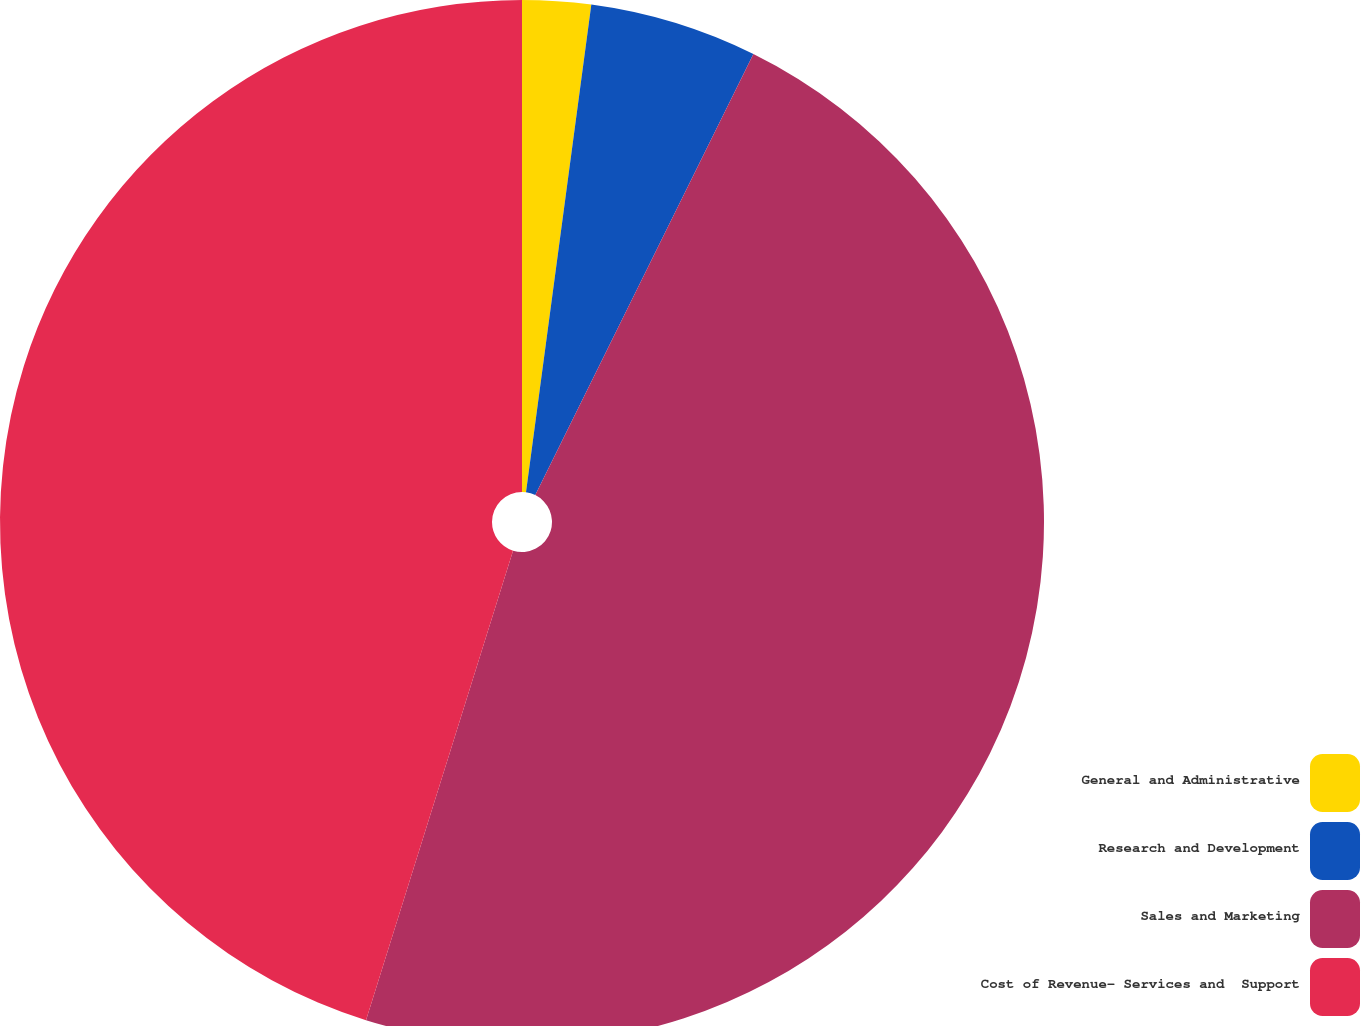Convert chart. <chart><loc_0><loc_0><loc_500><loc_500><pie_chart><fcel>General and Administrative<fcel>Research and Development<fcel>Sales and Marketing<fcel>Cost of Revenue- Services and  Support<nl><fcel>2.12%<fcel>5.19%<fcel>47.52%<fcel>45.17%<nl></chart> 